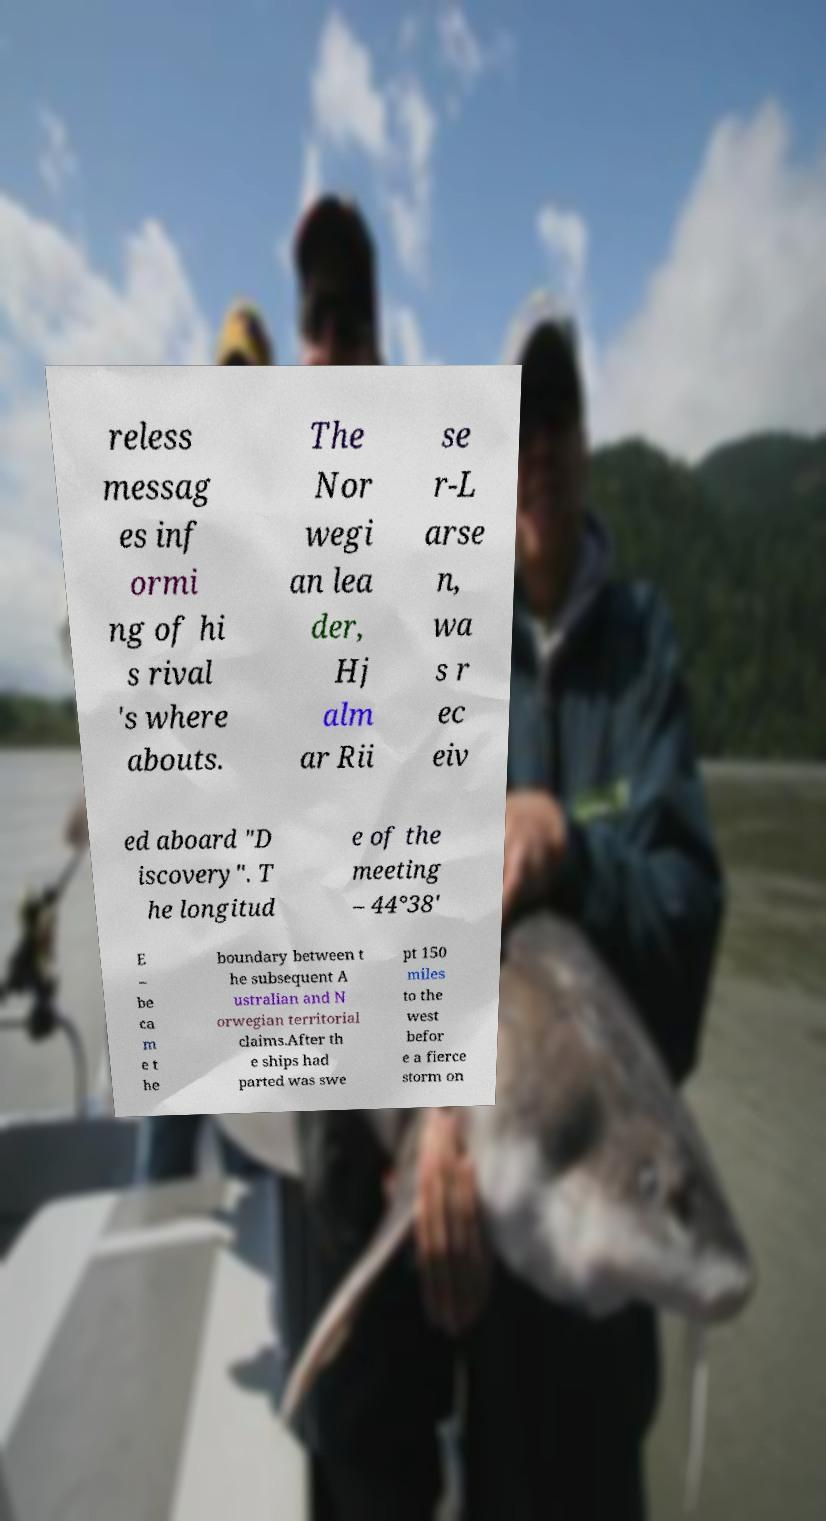Please read and relay the text visible in this image. What does it say? reless messag es inf ormi ng of hi s rival 's where abouts. The Nor wegi an lea der, Hj alm ar Rii se r-L arse n, wa s r ec eiv ed aboard "D iscovery". T he longitud e of the meeting – 44°38′ E – be ca m e t he boundary between t he subsequent A ustralian and N orwegian territorial claims.After th e ships had parted was swe pt 150 miles to the west befor e a fierce storm on 